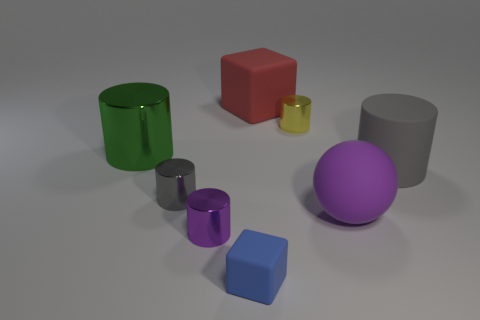Subtract all gray rubber cylinders. How many cylinders are left? 4 Subtract all gray spheres. How many gray cylinders are left? 2 Subtract all gray cylinders. How many cylinders are left? 3 Add 2 green shiny cylinders. How many objects exist? 10 Subtract all gray cylinders. Subtract all cyan spheres. How many cylinders are left? 3 Subtract all cylinders. How many objects are left? 3 Add 5 purple things. How many purple things exist? 7 Subtract 0 blue cylinders. How many objects are left? 8 Subtract all large cyan metallic objects. Subtract all cubes. How many objects are left? 6 Add 3 big rubber cylinders. How many big rubber cylinders are left? 4 